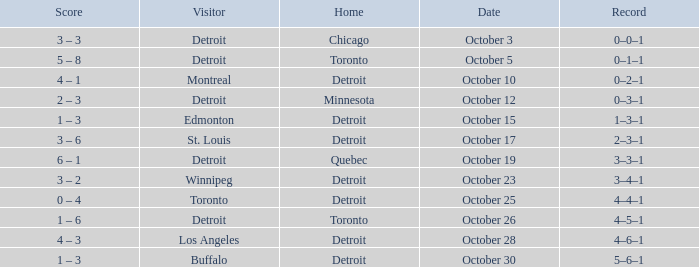Name the home with toronto visiting Detroit. 